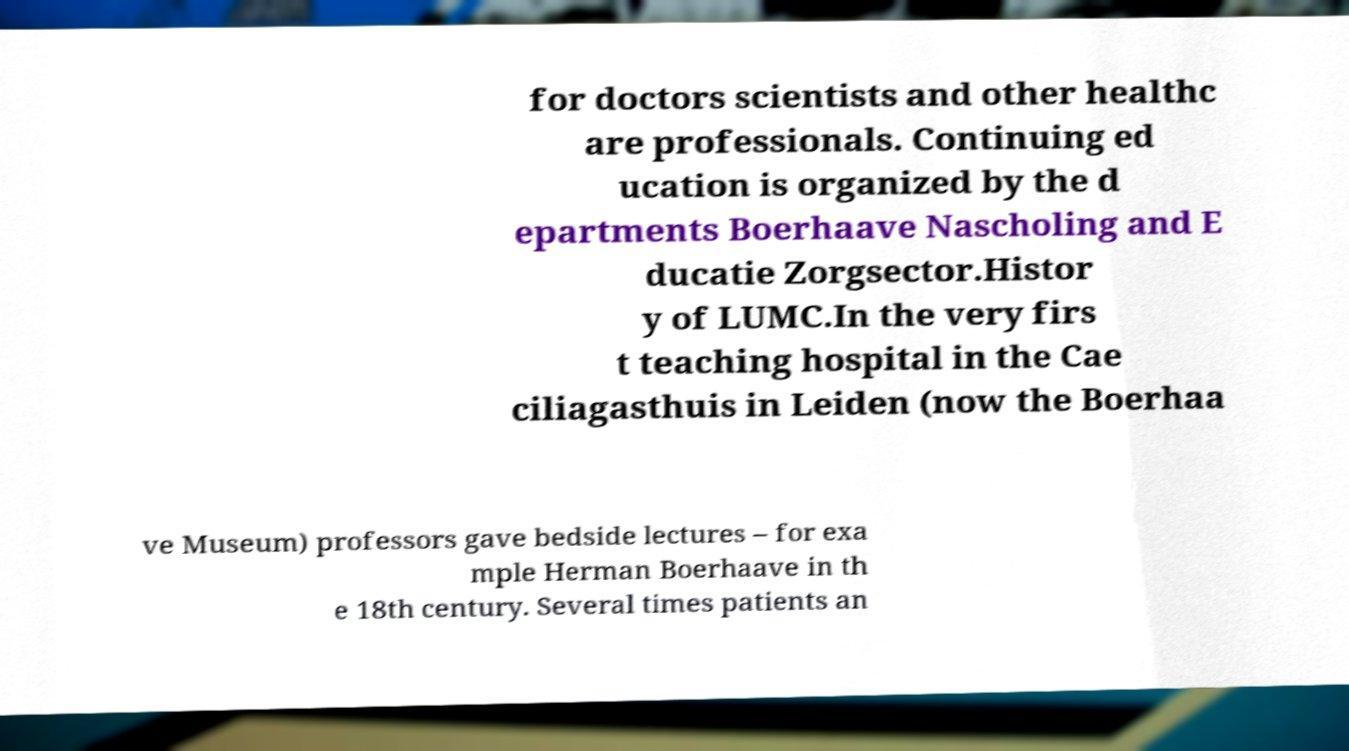What messages or text are displayed in this image? I need them in a readable, typed format. for doctors scientists and other healthc are professionals. Continuing ed ucation is organized by the d epartments Boerhaave Nascholing and E ducatie Zorgsector.Histor y of LUMC.In the very firs t teaching hospital in the Cae ciliagasthuis in Leiden (now the Boerhaa ve Museum) professors gave bedside lectures – for exa mple Herman Boerhaave in th e 18th century. Several times patients an 